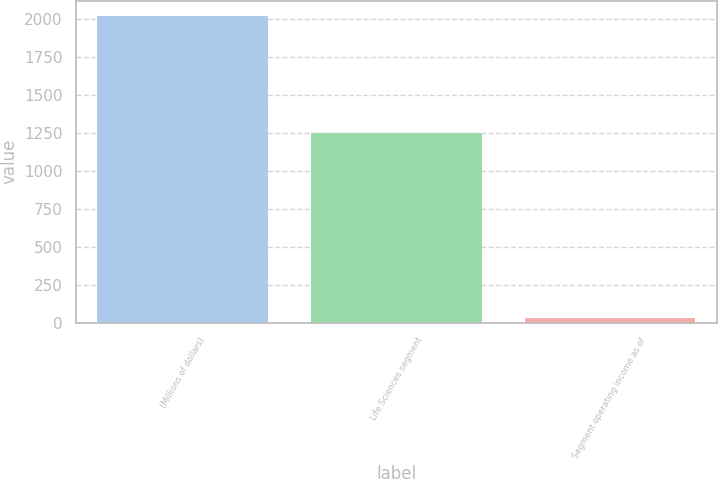<chart> <loc_0><loc_0><loc_500><loc_500><bar_chart><fcel>(Millions of dollars)<fcel>Life Sciences segment<fcel>Segment operating income as of<nl><fcel>2019<fcel>1248<fcel>29<nl></chart> 